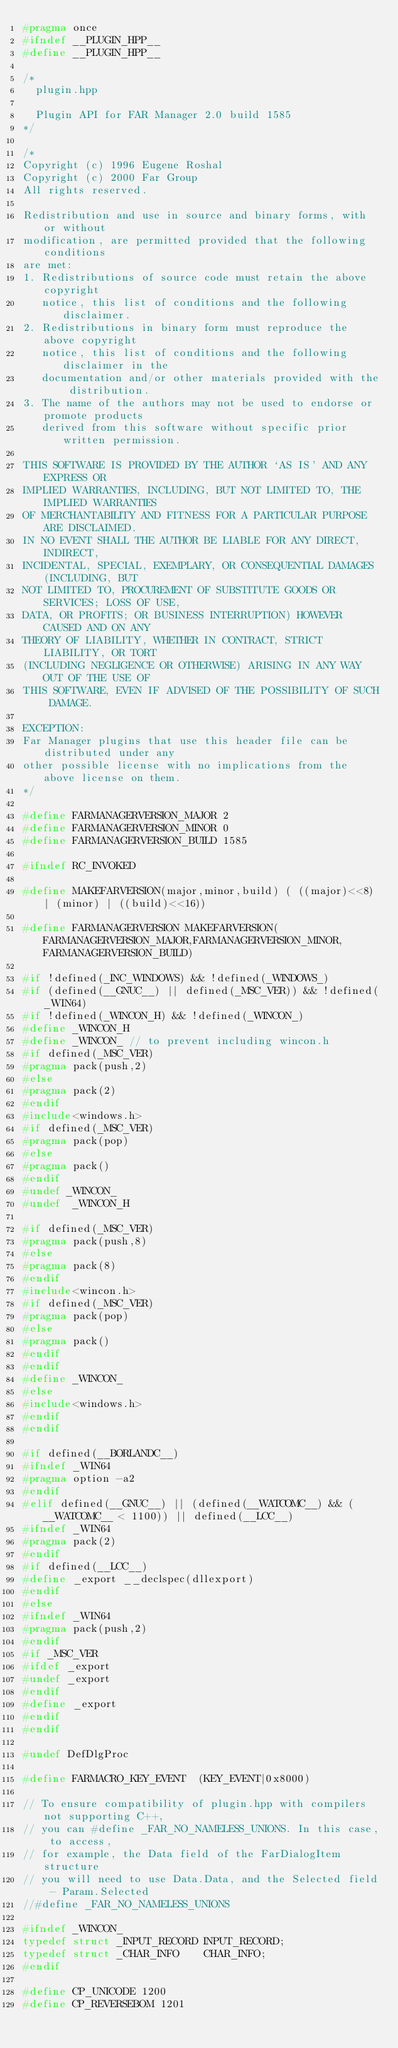<code> <loc_0><loc_0><loc_500><loc_500><_C++_>#pragma once
#ifndef __PLUGIN_HPP__
#define __PLUGIN_HPP__

/*
  plugin.hpp

  Plugin API for FAR Manager 2.0 build 1585
*/

/*
Copyright (c) 1996 Eugene Roshal
Copyright (c) 2000 Far Group
All rights reserved.

Redistribution and use in source and binary forms, with or without
modification, are permitted provided that the following conditions
are met:
1. Redistributions of source code must retain the above copyright
   notice, this list of conditions and the following disclaimer.
2. Redistributions in binary form must reproduce the above copyright
   notice, this list of conditions and the following disclaimer in the
   documentation and/or other materials provided with the distribution.
3. The name of the authors may not be used to endorse or promote products
   derived from this software without specific prior written permission.

THIS SOFTWARE IS PROVIDED BY THE AUTHOR `AS IS' AND ANY EXPRESS OR
IMPLIED WARRANTIES, INCLUDING, BUT NOT LIMITED TO, THE IMPLIED WARRANTIES
OF MERCHANTABILITY AND FITNESS FOR A PARTICULAR PURPOSE ARE DISCLAIMED.
IN NO EVENT SHALL THE AUTHOR BE LIABLE FOR ANY DIRECT, INDIRECT,
INCIDENTAL, SPECIAL, EXEMPLARY, OR CONSEQUENTIAL DAMAGES (INCLUDING, BUT
NOT LIMITED TO, PROCUREMENT OF SUBSTITUTE GOODS OR SERVICES; LOSS OF USE,
DATA, OR PROFITS; OR BUSINESS INTERRUPTION) HOWEVER CAUSED AND ON ANY
THEORY OF LIABILITY, WHETHER IN CONTRACT, STRICT LIABILITY, OR TORT
(INCLUDING NEGLIGENCE OR OTHERWISE) ARISING IN ANY WAY OUT OF THE USE OF
THIS SOFTWARE, EVEN IF ADVISED OF THE POSSIBILITY OF SUCH DAMAGE.

EXCEPTION:
Far Manager plugins that use this header file can be distributed under any
other possible license with no implications from the above license on them.
*/

#define FARMANAGERVERSION_MAJOR 2
#define FARMANAGERVERSION_MINOR 0
#define FARMANAGERVERSION_BUILD 1585

#ifndef RC_INVOKED

#define MAKEFARVERSION(major,minor,build) ( ((major)<<8) | (minor) | ((build)<<16))

#define FARMANAGERVERSION MAKEFARVERSION(FARMANAGERVERSION_MAJOR,FARMANAGERVERSION_MINOR,FARMANAGERVERSION_BUILD)

#if !defined(_INC_WINDOWS) && !defined(_WINDOWS_)
#if (defined(__GNUC__) || defined(_MSC_VER)) && !defined(_WIN64)
#if !defined(_WINCON_H) && !defined(_WINCON_)
#define _WINCON_H
#define _WINCON_ // to prevent including wincon.h
#if defined(_MSC_VER)
#pragma pack(push,2)
#else
#pragma pack(2)
#endif
#include<windows.h>
#if defined(_MSC_VER)
#pragma pack(pop)
#else
#pragma pack()
#endif
#undef _WINCON_
#undef  _WINCON_H

#if defined(_MSC_VER)
#pragma pack(push,8)
#else
#pragma pack(8)
#endif
#include<wincon.h>
#if defined(_MSC_VER)
#pragma pack(pop)
#else
#pragma pack()
#endif
#endif
#define _WINCON_
#else
#include<windows.h>
#endif
#endif

#if defined(__BORLANDC__)
#ifndef _WIN64
#pragma option -a2
#endif
#elif defined(__GNUC__) || (defined(__WATCOMC__) && (__WATCOMC__ < 1100)) || defined(__LCC__)
#ifndef _WIN64
#pragma pack(2)
#endif
#if defined(__LCC__)
#define _export __declspec(dllexport)
#endif
#else
#ifndef _WIN64
#pragma pack(push,2)
#endif
#if _MSC_VER
#ifdef _export
#undef _export
#endif
#define _export
#endif
#endif

#undef DefDlgProc

#define FARMACRO_KEY_EVENT  (KEY_EVENT|0x8000)

// To ensure compatibility of plugin.hpp with compilers not supporting C++,
// you can #define _FAR_NO_NAMELESS_UNIONS. In this case, to access,
// for example, the Data field of the FarDialogItem structure
// you will need to use Data.Data, and the Selected field - Param.Selected
//#define _FAR_NO_NAMELESS_UNIONS

#ifndef _WINCON_
typedef struct _INPUT_RECORD INPUT_RECORD;
typedef struct _CHAR_INFO    CHAR_INFO;
#endif

#define CP_UNICODE 1200
#define CP_REVERSEBOM 1201</code> 